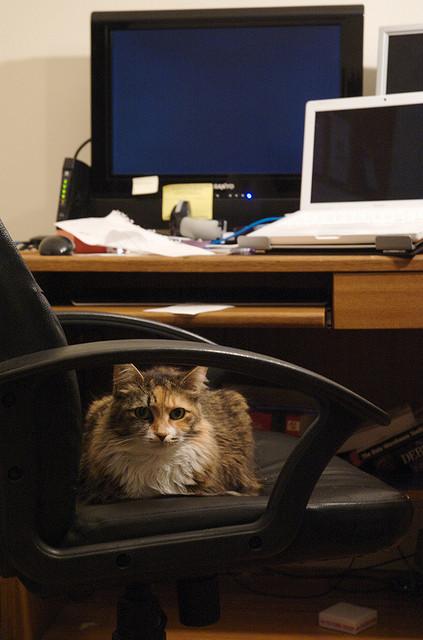How many screens?
Write a very short answer. 3. Where is the cat?
Be succinct. On chair. What is under the chair?
Concise answer only. Floor. 